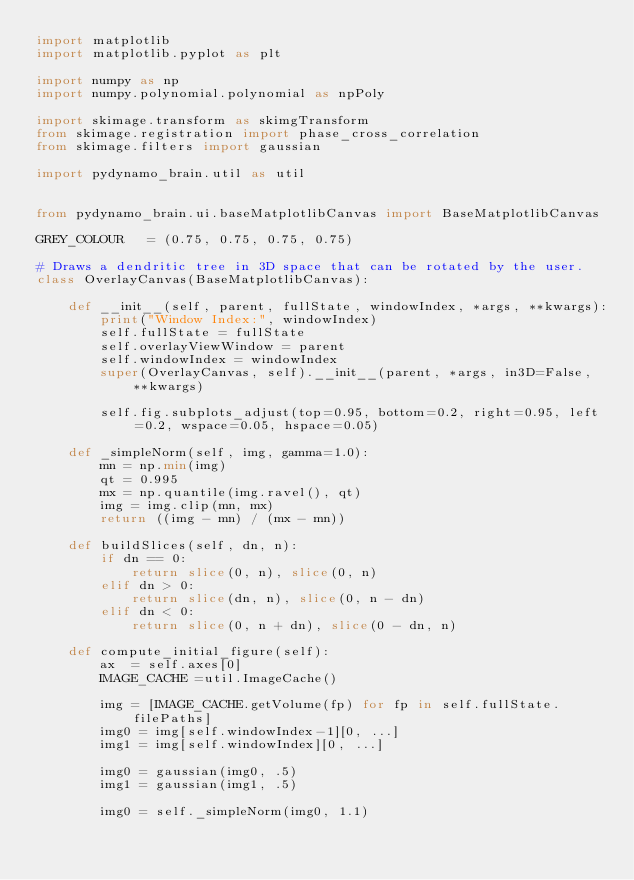<code> <loc_0><loc_0><loc_500><loc_500><_Python_>import matplotlib
import matplotlib.pyplot as plt

import numpy as np
import numpy.polynomial.polynomial as npPoly

import skimage.transform as skimgTransform
from skimage.registration import phase_cross_correlation
from skimage.filters import gaussian

import pydynamo_brain.util as util


from pydynamo_brain.ui.baseMatplotlibCanvas import BaseMatplotlibCanvas

GREY_COLOUR   = (0.75, 0.75, 0.75, 0.75)

# Draws a dendritic tree in 3D space that can be rotated by the user.
class OverlayCanvas(BaseMatplotlibCanvas):

    def __init__(self, parent, fullState, windowIndex, *args, **kwargs):
        print("Window Index:", windowIndex)
        self.fullState = fullState
        self.overlayViewWindow = parent
        self.windowIndex = windowIndex
        super(OverlayCanvas, self).__init__(parent, *args, in3D=False, **kwargs)

        self.fig.subplots_adjust(top=0.95, bottom=0.2, right=0.95, left=0.2, wspace=0.05, hspace=0.05)

    def _simpleNorm(self, img, gamma=1.0):
        mn = np.min(img)
        qt = 0.995
        mx = np.quantile(img.ravel(), qt)
        img = img.clip(mn, mx)
        return ((img - mn) / (mx - mn))

    def buildSlices(self, dn, n):
        if dn == 0:
            return slice(0, n), slice(0, n)
        elif dn > 0:
            return slice(dn, n), slice(0, n - dn)
        elif dn < 0:
            return slice(0, n + dn), slice(0 - dn, n)

    def compute_initial_figure(self):
        ax  = self.axes[0]
        IMAGE_CACHE =util.ImageCache()

        img = [IMAGE_CACHE.getVolume(fp) for fp in self.fullState.filePaths]
        img0 = img[self.windowIndex-1][0, ...]
        img1 = img[self.windowIndex][0, ...]

        img0 = gaussian(img0, .5)
        img1 = gaussian(img1, .5)

        img0 = self._simpleNorm(img0, 1.1)</code> 